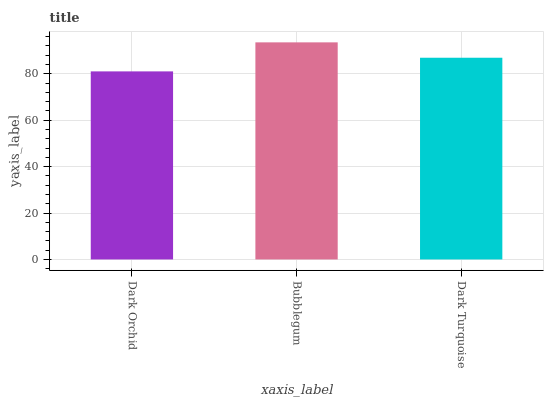Is Dark Orchid the minimum?
Answer yes or no. Yes. Is Bubblegum the maximum?
Answer yes or no. Yes. Is Dark Turquoise the minimum?
Answer yes or no. No. Is Dark Turquoise the maximum?
Answer yes or no. No. Is Bubblegum greater than Dark Turquoise?
Answer yes or no. Yes. Is Dark Turquoise less than Bubblegum?
Answer yes or no. Yes. Is Dark Turquoise greater than Bubblegum?
Answer yes or no. No. Is Bubblegum less than Dark Turquoise?
Answer yes or no. No. Is Dark Turquoise the high median?
Answer yes or no. Yes. Is Dark Turquoise the low median?
Answer yes or no. Yes. Is Dark Orchid the high median?
Answer yes or no. No. Is Bubblegum the low median?
Answer yes or no. No. 